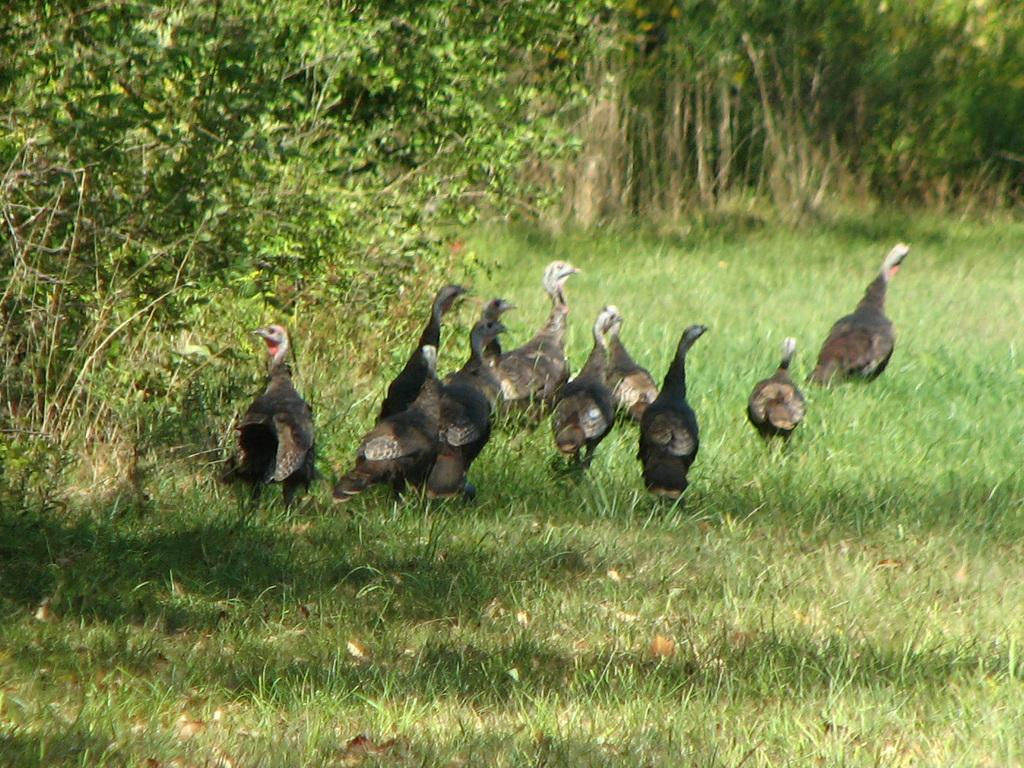What animals are in the center of the picture? There are hens in the center of the picture. What type of vegetation is in the foreground of the image? There is grass in the foreground. Where are the trees located in the image? There are trees on the left side of the image and in the background. What book is the rabbit reading in the image? There is no rabbit or book present in the image. How does the comparison between the hens and the trees help us understand the image better? The image does not involve any comparison between the hens and the trees, so this question cannot be answered definitively. 